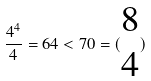<formula> <loc_0><loc_0><loc_500><loc_500>\frac { 4 ^ { 4 } } { 4 } = 6 4 < 7 0 = ( \begin{matrix} 8 \\ 4 \end{matrix} )</formula> 